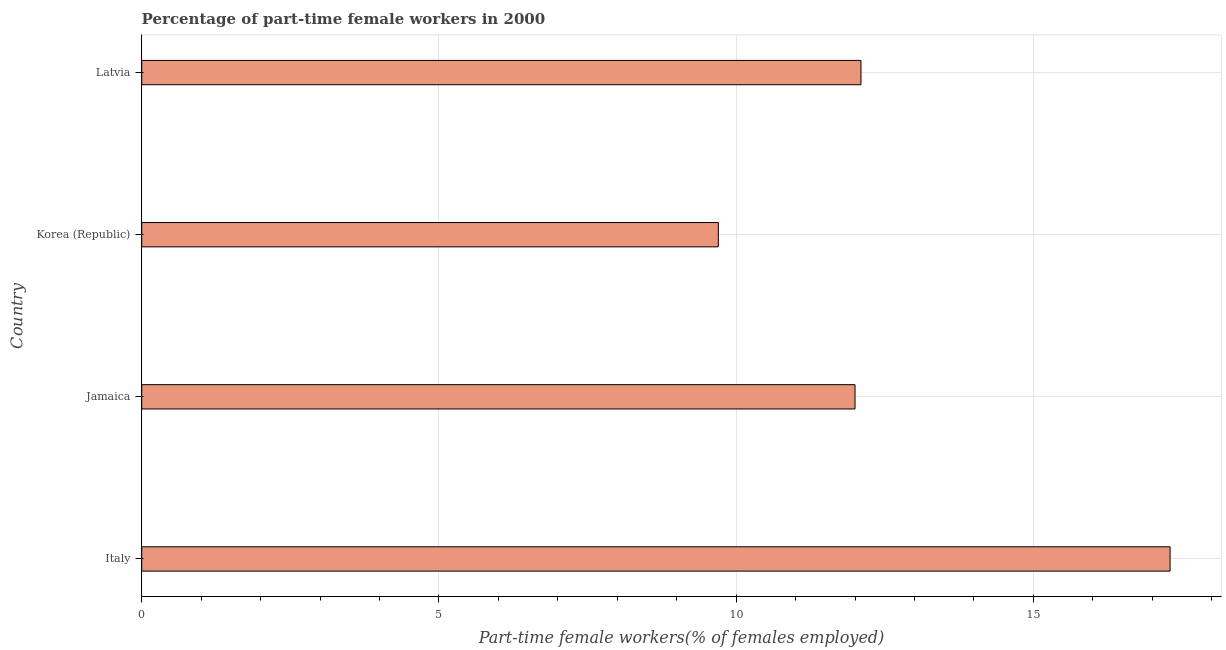Does the graph contain grids?
Offer a terse response. Yes. What is the title of the graph?
Offer a terse response. Percentage of part-time female workers in 2000. What is the label or title of the X-axis?
Offer a terse response. Part-time female workers(% of females employed). What is the percentage of part-time female workers in Latvia?
Keep it short and to the point. 12.1. Across all countries, what is the maximum percentage of part-time female workers?
Provide a succinct answer. 17.3. Across all countries, what is the minimum percentage of part-time female workers?
Offer a terse response. 9.7. In which country was the percentage of part-time female workers maximum?
Your response must be concise. Italy. In which country was the percentage of part-time female workers minimum?
Ensure brevity in your answer.  Korea (Republic). What is the sum of the percentage of part-time female workers?
Your response must be concise. 51.1. What is the average percentage of part-time female workers per country?
Your answer should be very brief. 12.78. What is the median percentage of part-time female workers?
Offer a very short reply. 12.05. What is the ratio of the percentage of part-time female workers in Jamaica to that in Latvia?
Your answer should be very brief. 0.99. Is the difference between the percentage of part-time female workers in Jamaica and Latvia greater than the difference between any two countries?
Keep it short and to the point. No. Is the sum of the percentage of part-time female workers in Italy and Jamaica greater than the maximum percentage of part-time female workers across all countries?
Provide a short and direct response. Yes. What is the difference between the highest and the lowest percentage of part-time female workers?
Provide a succinct answer. 7.6. In how many countries, is the percentage of part-time female workers greater than the average percentage of part-time female workers taken over all countries?
Your answer should be compact. 1. Are the values on the major ticks of X-axis written in scientific E-notation?
Keep it short and to the point. No. What is the Part-time female workers(% of females employed) in Italy?
Offer a terse response. 17.3. What is the Part-time female workers(% of females employed) of Korea (Republic)?
Your answer should be very brief. 9.7. What is the Part-time female workers(% of females employed) in Latvia?
Provide a succinct answer. 12.1. What is the difference between the Part-time female workers(% of females employed) in Italy and Jamaica?
Make the answer very short. 5.3. What is the difference between the Part-time female workers(% of females employed) in Jamaica and Korea (Republic)?
Provide a succinct answer. 2.3. What is the difference between the Part-time female workers(% of females employed) in Korea (Republic) and Latvia?
Give a very brief answer. -2.4. What is the ratio of the Part-time female workers(% of females employed) in Italy to that in Jamaica?
Your answer should be very brief. 1.44. What is the ratio of the Part-time female workers(% of females employed) in Italy to that in Korea (Republic)?
Provide a short and direct response. 1.78. What is the ratio of the Part-time female workers(% of females employed) in Italy to that in Latvia?
Provide a succinct answer. 1.43. What is the ratio of the Part-time female workers(% of females employed) in Jamaica to that in Korea (Republic)?
Make the answer very short. 1.24. What is the ratio of the Part-time female workers(% of females employed) in Korea (Republic) to that in Latvia?
Provide a succinct answer. 0.8. 